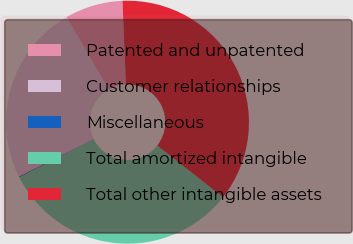<chart> <loc_0><loc_0><loc_500><loc_500><pie_chart><fcel>Patented and unpatented<fcel>Customer relationships<fcel>Miscellaneous<fcel>Total amortized intangible<fcel>Total other intangible assets<nl><fcel>7.71%<fcel>24.03%<fcel>0.13%<fcel>31.87%<fcel>36.26%<nl></chart> 